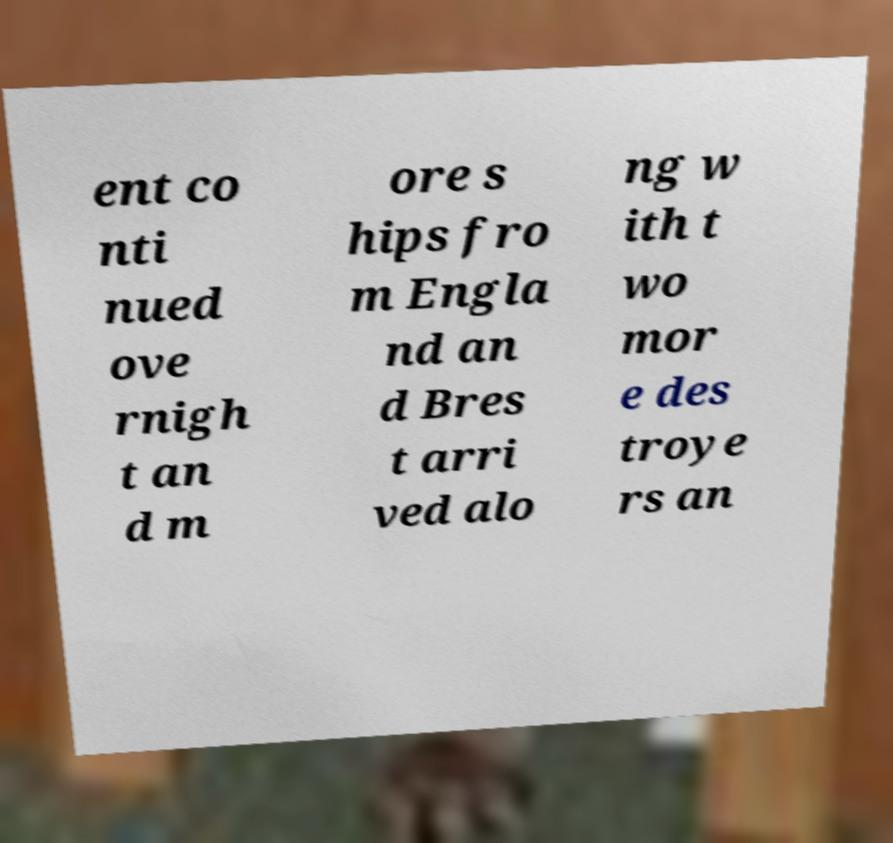What messages or text are displayed in this image? I need them in a readable, typed format. ent co nti nued ove rnigh t an d m ore s hips fro m Engla nd an d Bres t arri ved alo ng w ith t wo mor e des troye rs an 